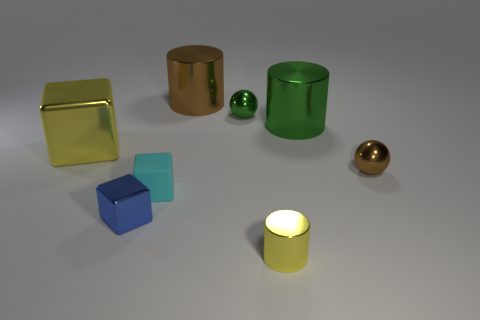Add 2 small brown metallic cylinders. How many objects exist? 10 Subtract all balls. How many objects are left? 6 Add 3 green objects. How many green objects are left? 5 Add 2 small brown balls. How many small brown balls exist? 3 Subtract 0 blue cylinders. How many objects are left? 8 Subtract all big cyan things. Subtract all big brown shiny cylinders. How many objects are left? 7 